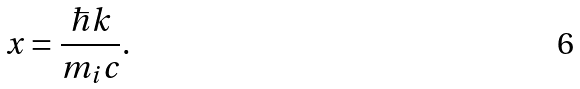Convert formula to latex. <formula><loc_0><loc_0><loc_500><loc_500>x = \frac { \hbar { k } } { m _ { i } c } .</formula> 